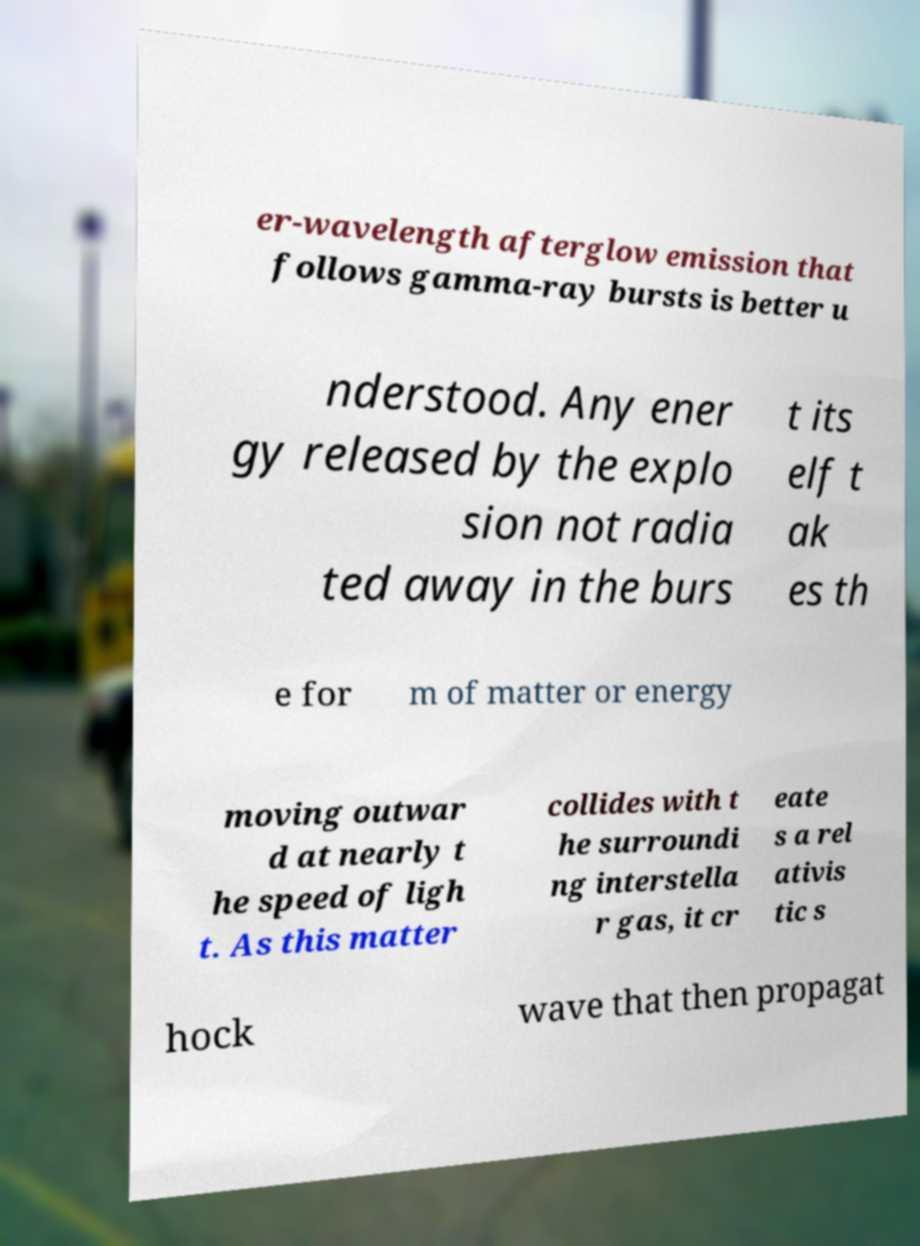I need the written content from this picture converted into text. Can you do that? er-wavelength afterglow emission that follows gamma-ray bursts is better u nderstood. Any ener gy released by the explo sion not radia ted away in the burs t its elf t ak es th e for m of matter or energy moving outwar d at nearly t he speed of ligh t. As this matter collides with t he surroundi ng interstella r gas, it cr eate s a rel ativis tic s hock wave that then propagat 